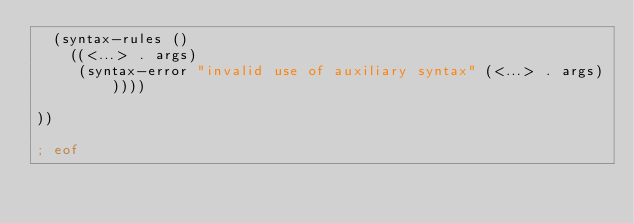<code> <loc_0><loc_0><loc_500><loc_500><_Scheme_>  (syntax-rules ()
    ((<...> . args)
     (syntax-error "invalid use of auxiliary syntax" (<...> . args)))))

))

; eof
</code> 